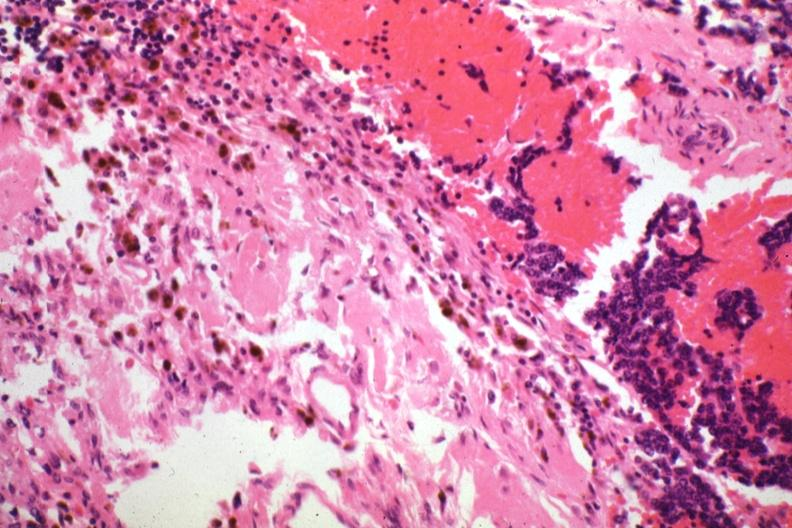what is present?
Answer the question using a single word or phrase. Pituitary 